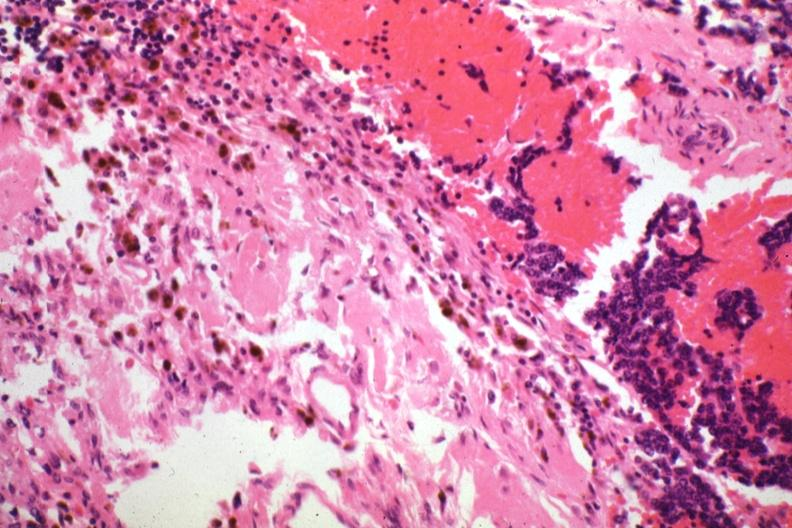what is present?
Answer the question using a single word or phrase. Pituitary 